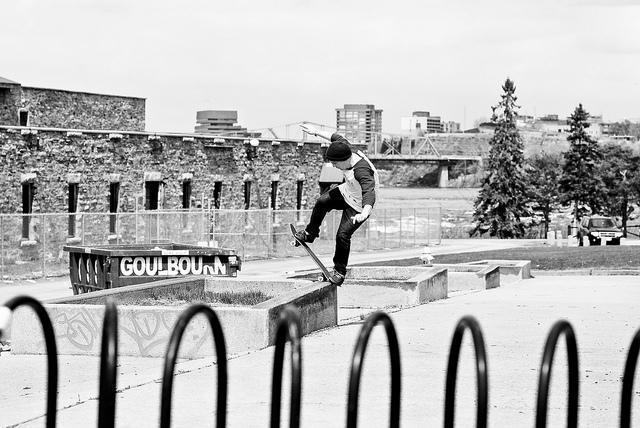How many ovens are there?
Give a very brief answer. 0. 